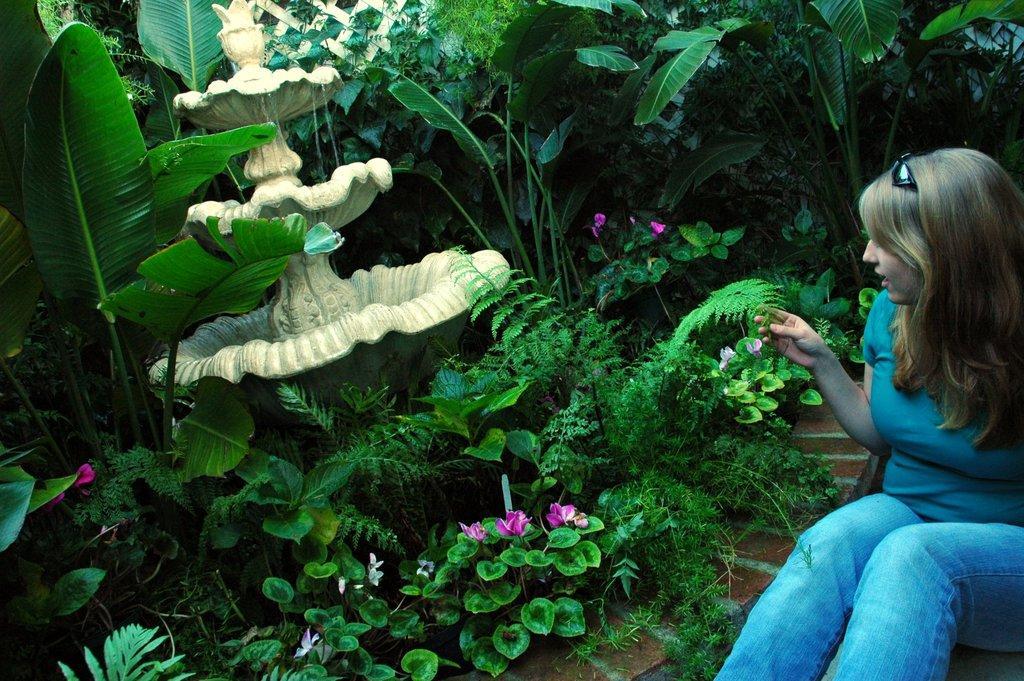In one or two sentences, can you explain what this image depicts? In this picture we can see a woman is sitting on the right side, on the left side we can see some plants, trees and flowers, it looks like a fountain in the middle. 